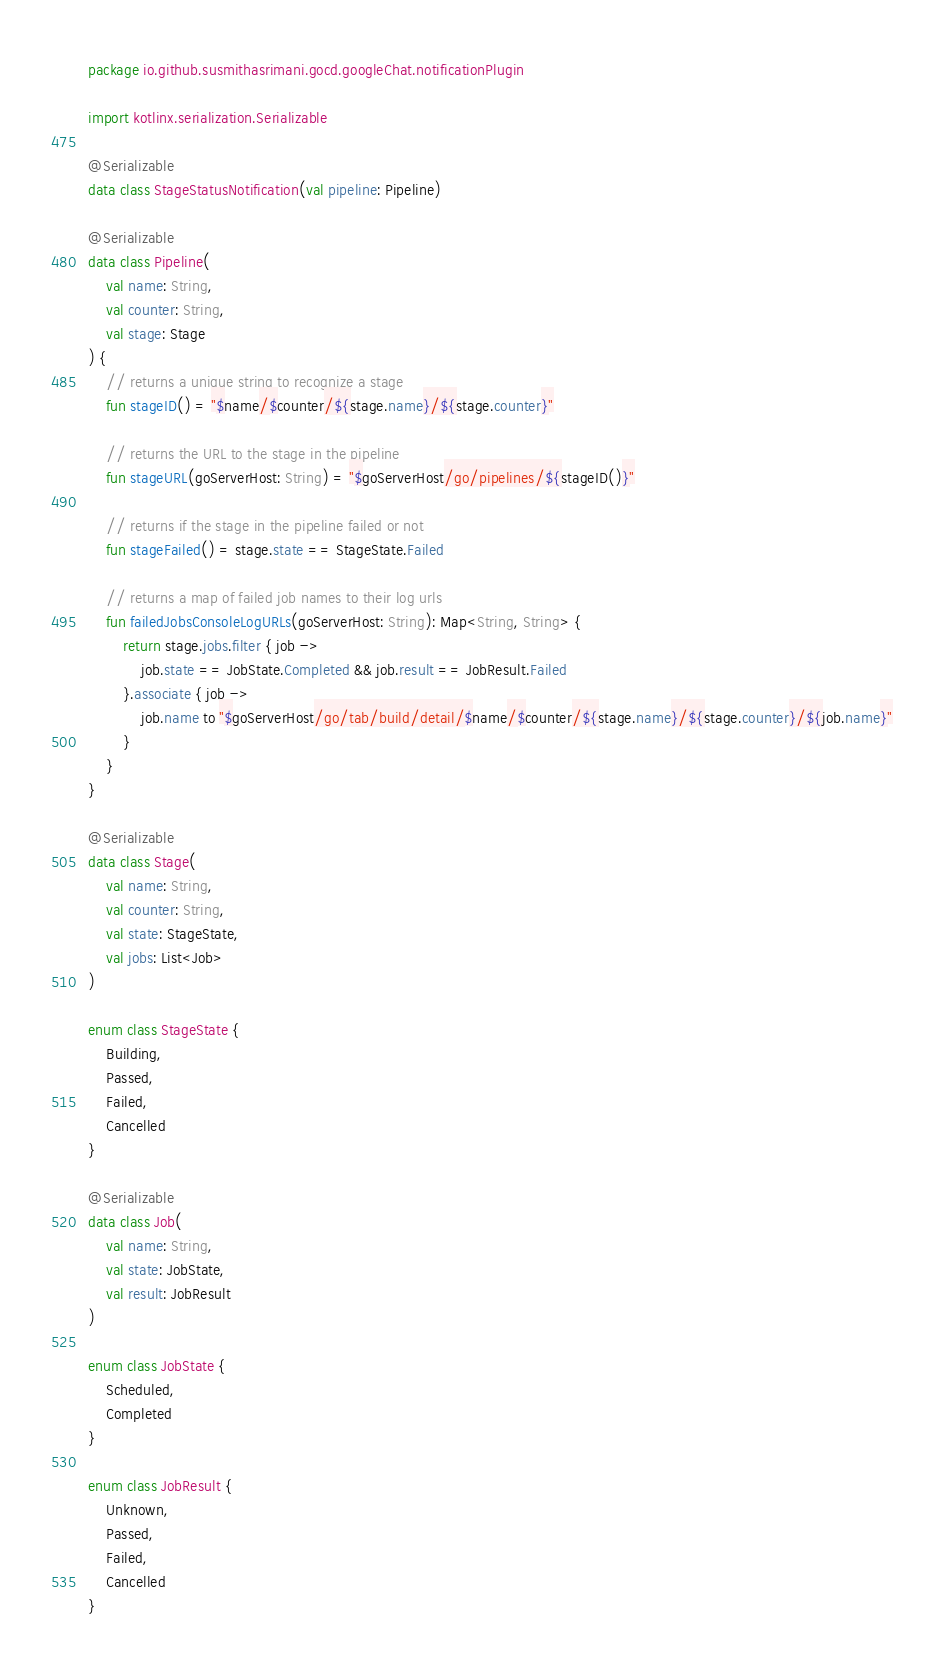Convert code to text. <code><loc_0><loc_0><loc_500><loc_500><_Kotlin_>package io.github.susmithasrimani.gocd.googleChat.notificationPlugin

import kotlinx.serialization.Serializable

@Serializable
data class StageStatusNotification(val pipeline: Pipeline)

@Serializable
data class Pipeline(
    val name: String,
    val counter: String,
    val stage: Stage
) {
    // returns a unique string to recognize a stage
    fun stageID() = "$name/$counter/${stage.name}/${stage.counter}"

    // returns the URL to the stage in the pipeline
    fun stageURL(goServerHost: String) = "$goServerHost/go/pipelines/${stageID()}"

    // returns if the stage in the pipeline failed or not
    fun stageFailed() = stage.state == StageState.Failed

    // returns a map of failed job names to their log urls
    fun failedJobsConsoleLogURLs(goServerHost: String): Map<String, String> {
        return stage.jobs.filter { job ->
            job.state == JobState.Completed && job.result == JobResult.Failed
        }.associate { job ->
            job.name to "$goServerHost/go/tab/build/detail/$name/$counter/${stage.name}/${stage.counter}/${job.name}"
        }
    }
}

@Serializable
data class Stage(
    val name: String,
    val counter: String,
    val state: StageState,
    val jobs: List<Job>
)

enum class StageState {
    Building,
    Passed,
    Failed,
    Cancelled
}

@Serializable
data class Job(
    val name: String,
    val state: JobState,
    val result: JobResult
)

enum class JobState {
    Scheduled,
    Completed
}

enum class JobResult {
    Unknown,
    Passed,
    Failed,
    Cancelled
}
</code> 